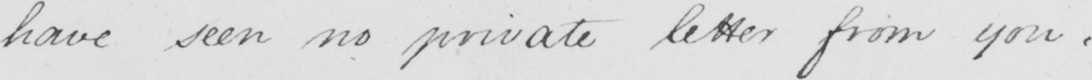What does this handwritten line say? have seen no private letter from you :   _ 